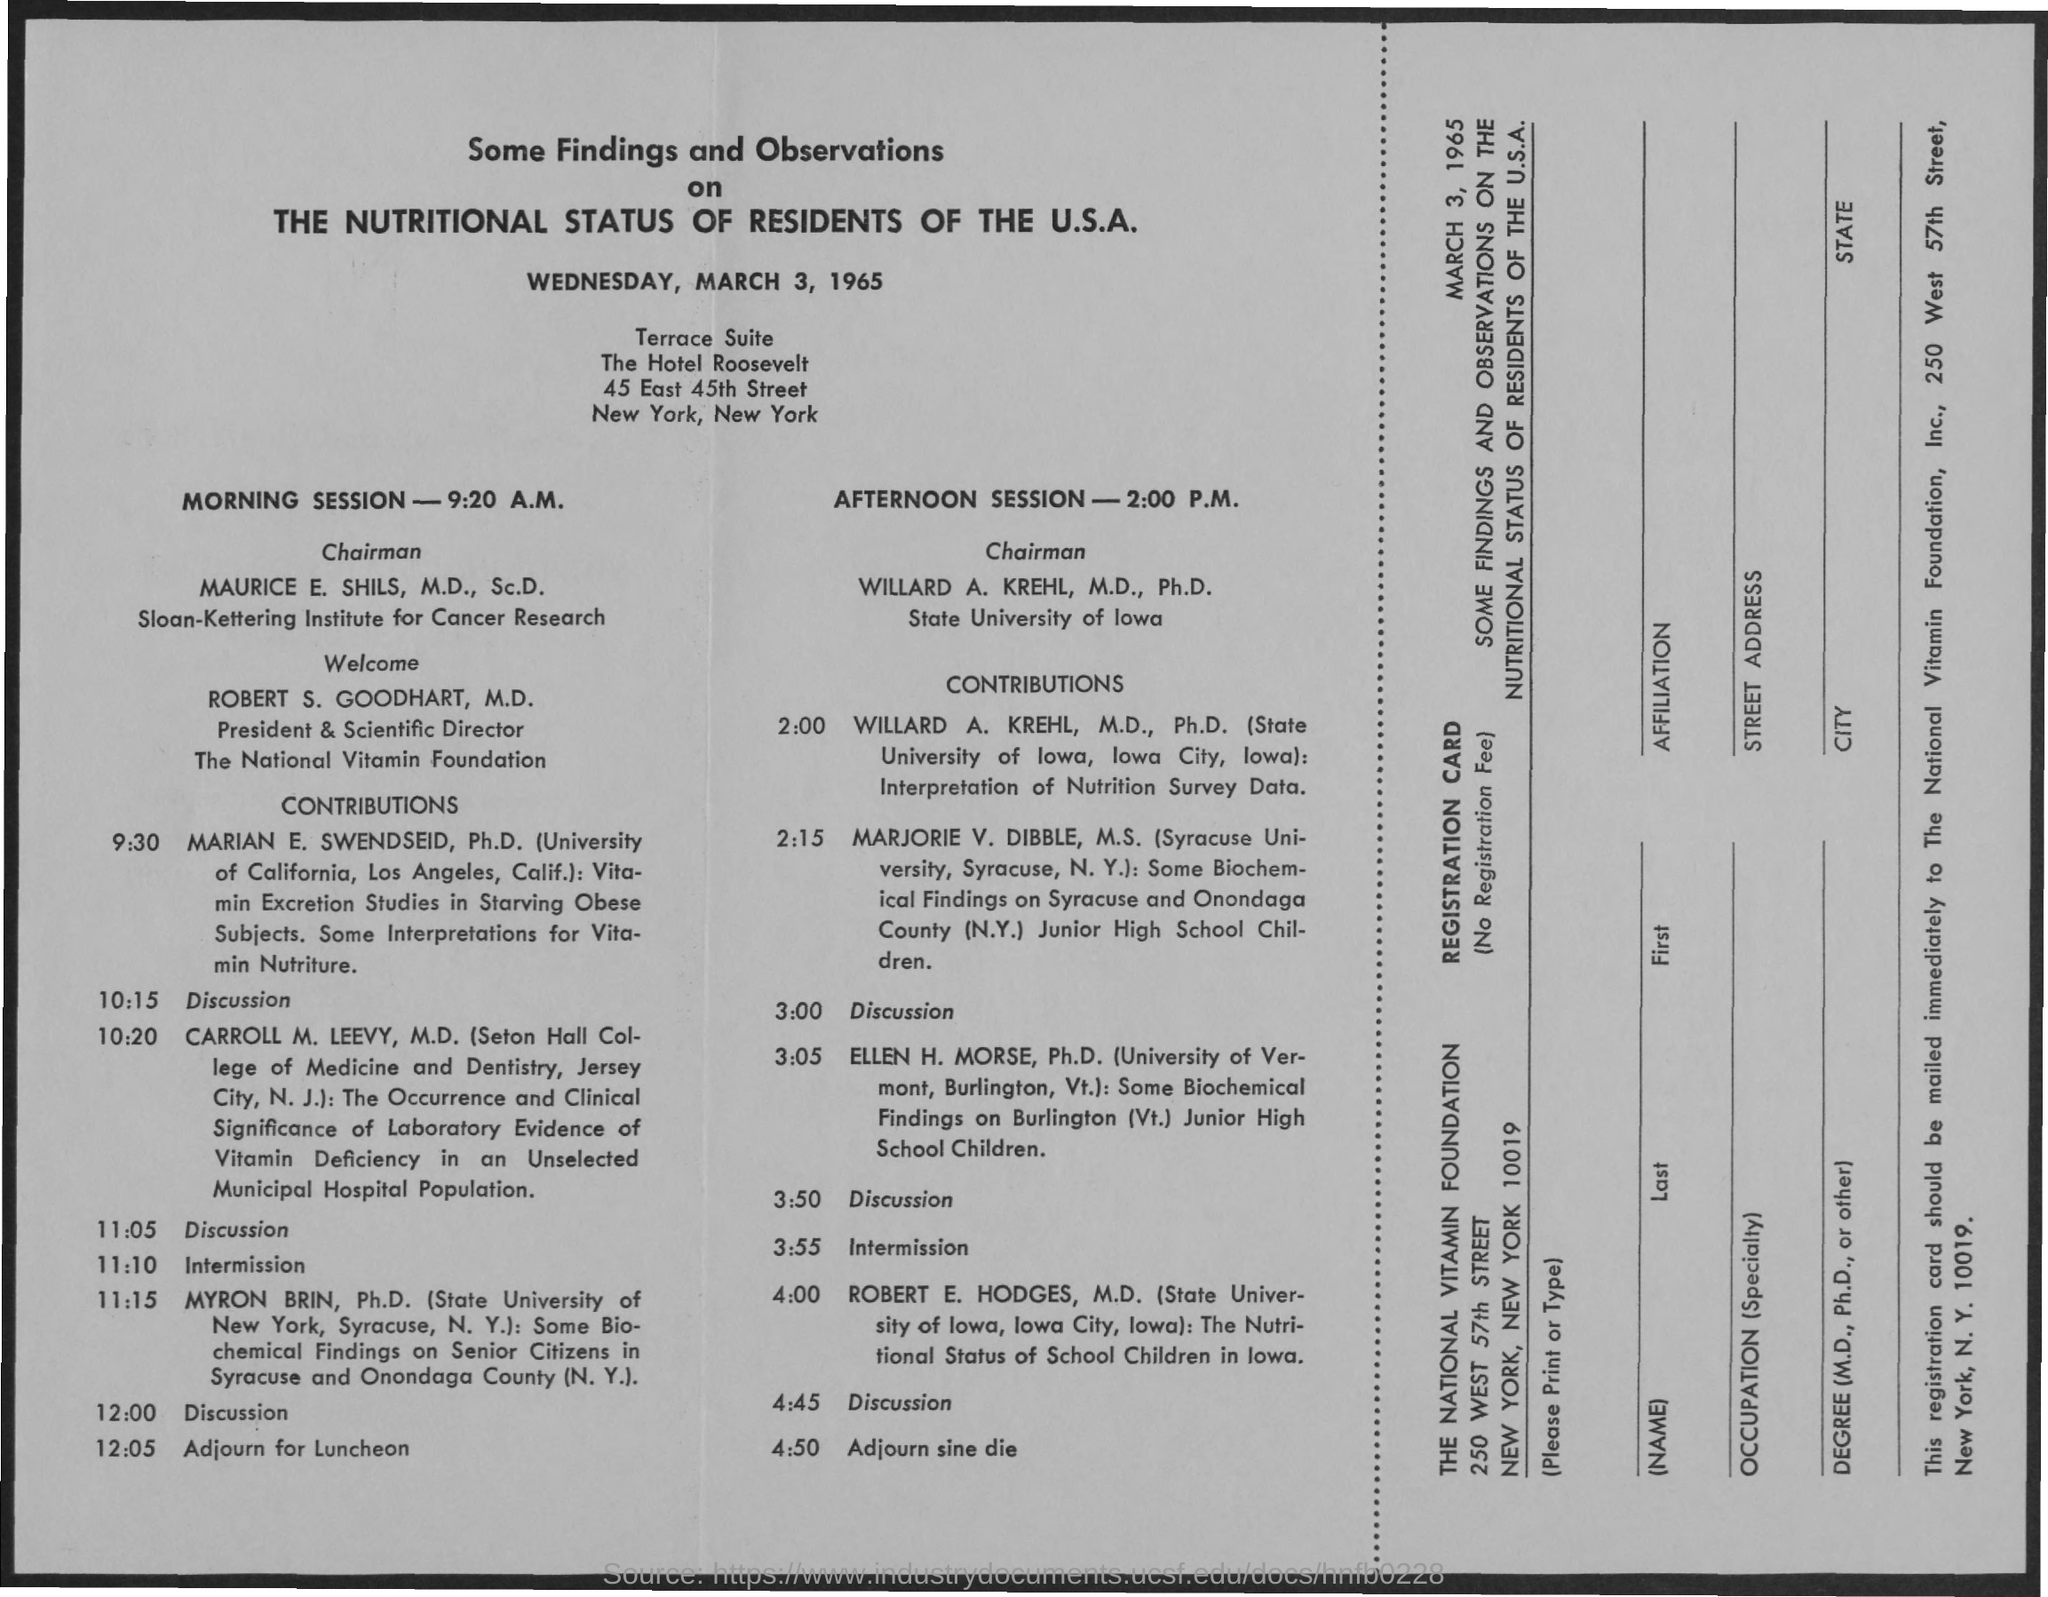Give some essential details in this illustration. The date mentioned in the document is Wednesday, March 3, 1965. 